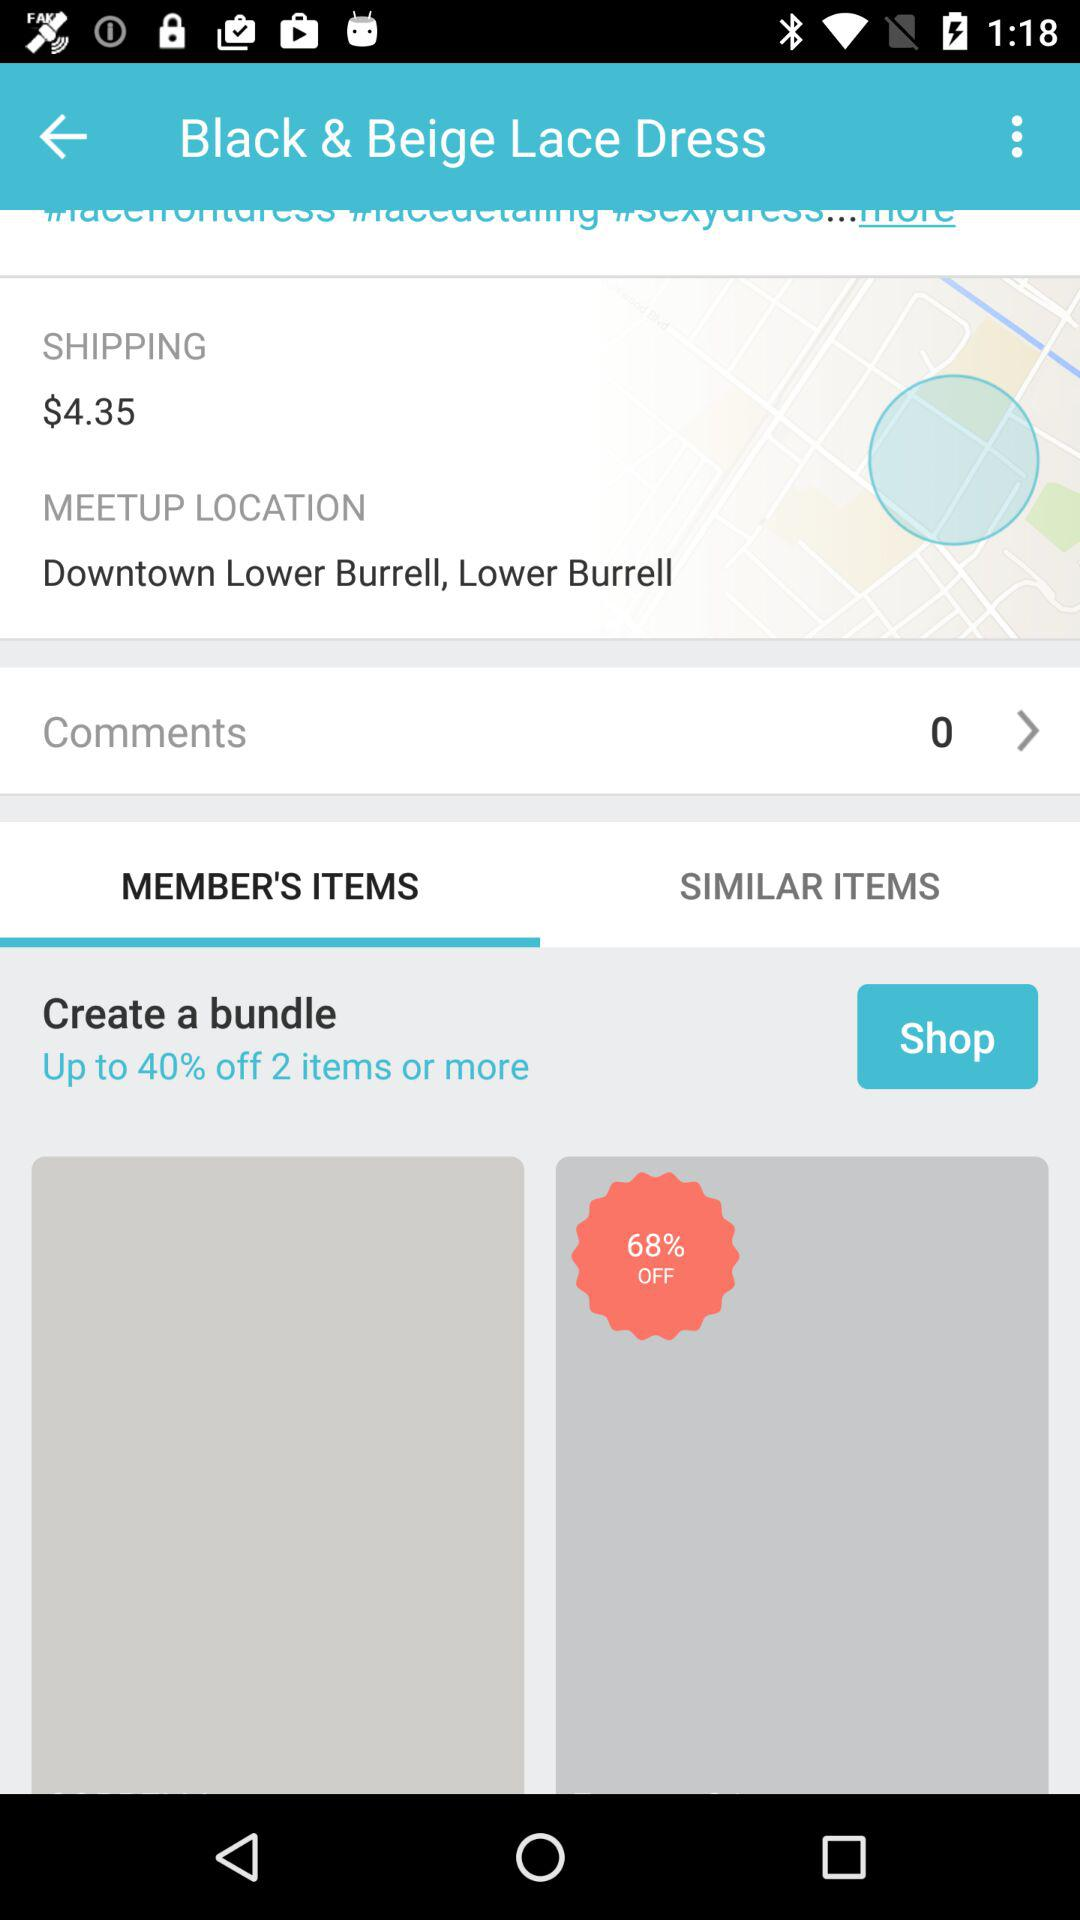What is the offer on the bundle? There is up to 40% off on the bundle. 